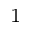Convert formula to latex. <formula><loc_0><loc_0><loc_500><loc_500>^ { 1 }</formula> 